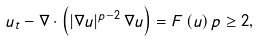Convert formula to latex. <formula><loc_0><loc_0><loc_500><loc_500>u _ { t } - \nabla \cdot \left ( \left | \nabla u \right | ^ { p - 2 } \nabla u \right ) = F \left ( u \right ) p \geq 2 ,</formula> 